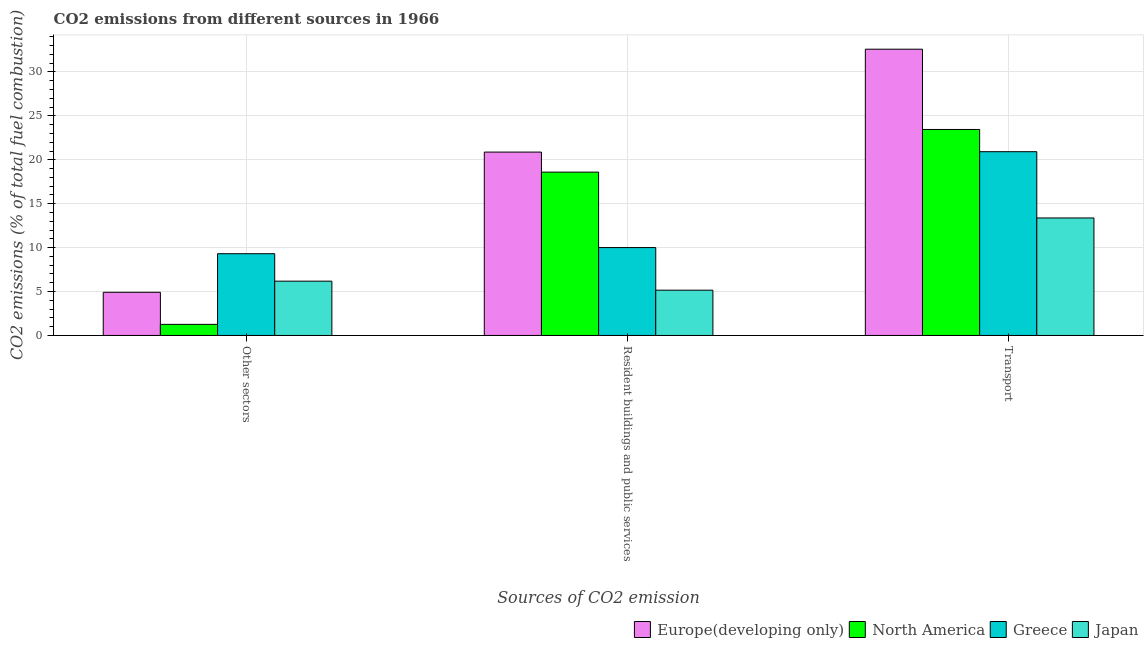How many groups of bars are there?
Provide a succinct answer. 3. Are the number of bars per tick equal to the number of legend labels?
Your response must be concise. Yes. How many bars are there on the 1st tick from the right?
Give a very brief answer. 4. What is the label of the 3rd group of bars from the left?
Provide a succinct answer. Transport. What is the percentage of co2 emissions from other sectors in Japan?
Offer a terse response. 6.18. Across all countries, what is the maximum percentage of co2 emissions from other sectors?
Provide a succinct answer. 9.31. Across all countries, what is the minimum percentage of co2 emissions from transport?
Give a very brief answer. 13.38. In which country was the percentage of co2 emissions from resident buildings and public services maximum?
Keep it short and to the point. Europe(developing only). In which country was the percentage of co2 emissions from other sectors minimum?
Make the answer very short. North America. What is the total percentage of co2 emissions from transport in the graph?
Keep it short and to the point. 90.35. What is the difference between the percentage of co2 emissions from transport in North America and that in Europe(developing only)?
Offer a very short reply. -9.14. What is the difference between the percentage of co2 emissions from other sectors in Europe(developing only) and the percentage of co2 emissions from resident buildings and public services in North America?
Ensure brevity in your answer.  -13.68. What is the average percentage of co2 emissions from resident buildings and public services per country?
Provide a succinct answer. 13.66. What is the difference between the percentage of co2 emissions from other sectors and percentage of co2 emissions from transport in North America?
Ensure brevity in your answer.  -22.19. What is the ratio of the percentage of co2 emissions from other sectors in Greece to that in North America?
Provide a short and direct response. 7.37. Is the percentage of co2 emissions from other sectors in Greece less than that in Europe(developing only)?
Offer a very short reply. No. What is the difference between the highest and the second highest percentage of co2 emissions from resident buildings and public services?
Provide a short and direct response. 2.28. What is the difference between the highest and the lowest percentage of co2 emissions from other sectors?
Offer a terse response. 8.04. In how many countries, is the percentage of co2 emissions from other sectors greater than the average percentage of co2 emissions from other sectors taken over all countries?
Your response must be concise. 2. What does the 2nd bar from the left in Other sectors represents?
Ensure brevity in your answer.  North America. What does the 2nd bar from the right in Other sectors represents?
Provide a short and direct response. Greece. Where does the legend appear in the graph?
Your response must be concise. Bottom right. How are the legend labels stacked?
Give a very brief answer. Horizontal. What is the title of the graph?
Your answer should be compact. CO2 emissions from different sources in 1966. What is the label or title of the X-axis?
Offer a terse response. Sources of CO2 emission. What is the label or title of the Y-axis?
Offer a very short reply. CO2 emissions (% of total fuel combustion). What is the CO2 emissions (% of total fuel combustion) in Europe(developing only) in Other sectors?
Your response must be concise. 4.92. What is the CO2 emissions (% of total fuel combustion) of North America in Other sectors?
Offer a terse response. 1.26. What is the CO2 emissions (% of total fuel combustion) of Greece in Other sectors?
Your answer should be compact. 9.31. What is the CO2 emissions (% of total fuel combustion) of Japan in Other sectors?
Ensure brevity in your answer.  6.18. What is the CO2 emissions (% of total fuel combustion) in Europe(developing only) in Resident buildings and public services?
Your answer should be compact. 20.88. What is the CO2 emissions (% of total fuel combustion) of North America in Resident buildings and public services?
Provide a succinct answer. 18.6. What is the CO2 emissions (% of total fuel combustion) of Greece in Resident buildings and public services?
Provide a succinct answer. 10.01. What is the CO2 emissions (% of total fuel combustion) of Japan in Resident buildings and public services?
Make the answer very short. 5.16. What is the CO2 emissions (% of total fuel combustion) in Europe(developing only) in Transport?
Your answer should be very brief. 32.59. What is the CO2 emissions (% of total fuel combustion) of North America in Transport?
Your response must be concise. 23.45. What is the CO2 emissions (% of total fuel combustion) of Greece in Transport?
Your answer should be compact. 20.92. What is the CO2 emissions (% of total fuel combustion) of Japan in Transport?
Keep it short and to the point. 13.38. Across all Sources of CO2 emission, what is the maximum CO2 emissions (% of total fuel combustion) in Europe(developing only)?
Provide a succinct answer. 32.59. Across all Sources of CO2 emission, what is the maximum CO2 emissions (% of total fuel combustion) of North America?
Give a very brief answer. 23.45. Across all Sources of CO2 emission, what is the maximum CO2 emissions (% of total fuel combustion) in Greece?
Offer a terse response. 20.92. Across all Sources of CO2 emission, what is the maximum CO2 emissions (% of total fuel combustion) in Japan?
Keep it short and to the point. 13.38. Across all Sources of CO2 emission, what is the minimum CO2 emissions (% of total fuel combustion) in Europe(developing only)?
Your answer should be very brief. 4.92. Across all Sources of CO2 emission, what is the minimum CO2 emissions (% of total fuel combustion) of North America?
Your answer should be very brief. 1.26. Across all Sources of CO2 emission, what is the minimum CO2 emissions (% of total fuel combustion) in Greece?
Offer a terse response. 9.31. Across all Sources of CO2 emission, what is the minimum CO2 emissions (% of total fuel combustion) of Japan?
Give a very brief answer. 5.16. What is the total CO2 emissions (% of total fuel combustion) of Europe(developing only) in the graph?
Give a very brief answer. 58.39. What is the total CO2 emissions (% of total fuel combustion) in North America in the graph?
Provide a short and direct response. 43.31. What is the total CO2 emissions (% of total fuel combustion) in Greece in the graph?
Keep it short and to the point. 40.24. What is the total CO2 emissions (% of total fuel combustion) of Japan in the graph?
Your answer should be compact. 24.72. What is the difference between the CO2 emissions (% of total fuel combustion) of Europe(developing only) in Other sectors and that in Resident buildings and public services?
Give a very brief answer. -15.96. What is the difference between the CO2 emissions (% of total fuel combustion) of North America in Other sectors and that in Resident buildings and public services?
Your answer should be compact. -17.33. What is the difference between the CO2 emissions (% of total fuel combustion) in Greece in Other sectors and that in Resident buildings and public services?
Your response must be concise. -0.7. What is the difference between the CO2 emissions (% of total fuel combustion) of Japan in Other sectors and that in Resident buildings and public services?
Offer a very short reply. 1.03. What is the difference between the CO2 emissions (% of total fuel combustion) of Europe(developing only) in Other sectors and that in Transport?
Keep it short and to the point. -27.68. What is the difference between the CO2 emissions (% of total fuel combustion) in North America in Other sectors and that in Transport?
Make the answer very short. -22.19. What is the difference between the CO2 emissions (% of total fuel combustion) in Greece in Other sectors and that in Transport?
Your answer should be very brief. -11.62. What is the difference between the CO2 emissions (% of total fuel combustion) of Japan in Other sectors and that in Transport?
Your answer should be compact. -7.2. What is the difference between the CO2 emissions (% of total fuel combustion) of Europe(developing only) in Resident buildings and public services and that in Transport?
Ensure brevity in your answer.  -11.71. What is the difference between the CO2 emissions (% of total fuel combustion) of North America in Resident buildings and public services and that in Transport?
Offer a terse response. -4.86. What is the difference between the CO2 emissions (% of total fuel combustion) of Greece in Resident buildings and public services and that in Transport?
Make the answer very short. -10.92. What is the difference between the CO2 emissions (% of total fuel combustion) in Japan in Resident buildings and public services and that in Transport?
Provide a short and direct response. -8.22. What is the difference between the CO2 emissions (% of total fuel combustion) in Europe(developing only) in Other sectors and the CO2 emissions (% of total fuel combustion) in North America in Resident buildings and public services?
Your answer should be compact. -13.68. What is the difference between the CO2 emissions (% of total fuel combustion) of Europe(developing only) in Other sectors and the CO2 emissions (% of total fuel combustion) of Greece in Resident buildings and public services?
Provide a short and direct response. -5.09. What is the difference between the CO2 emissions (% of total fuel combustion) in Europe(developing only) in Other sectors and the CO2 emissions (% of total fuel combustion) in Japan in Resident buildings and public services?
Make the answer very short. -0.24. What is the difference between the CO2 emissions (% of total fuel combustion) in North America in Other sectors and the CO2 emissions (% of total fuel combustion) in Greece in Resident buildings and public services?
Provide a succinct answer. -8.74. What is the difference between the CO2 emissions (% of total fuel combustion) in North America in Other sectors and the CO2 emissions (% of total fuel combustion) in Japan in Resident buildings and public services?
Keep it short and to the point. -3.89. What is the difference between the CO2 emissions (% of total fuel combustion) of Greece in Other sectors and the CO2 emissions (% of total fuel combustion) of Japan in Resident buildings and public services?
Keep it short and to the point. 4.15. What is the difference between the CO2 emissions (% of total fuel combustion) in Europe(developing only) in Other sectors and the CO2 emissions (% of total fuel combustion) in North America in Transport?
Make the answer very short. -18.54. What is the difference between the CO2 emissions (% of total fuel combustion) in Europe(developing only) in Other sectors and the CO2 emissions (% of total fuel combustion) in Greece in Transport?
Provide a short and direct response. -16.01. What is the difference between the CO2 emissions (% of total fuel combustion) in Europe(developing only) in Other sectors and the CO2 emissions (% of total fuel combustion) in Japan in Transport?
Offer a terse response. -8.46. What is the difference between the CO2 emissions (% of total fuel combustion) of North America in Other sectors and the CO2 emissions (% of total fuel combustion) of Greece in Transport?
Your answer should be compact. -19.66. What is the difference between the CO2 emissions (% of total fuel combustion) of North America in Other sectors and the CO2 emissions (% of total fuel combustion) of Japan in Transport?
Ensure brevity in your answer.  -12.12. What is the difference between the CO2 emissions (% of total fuel combustion) in Greece in Other sectors and the CO2 emissions (% of total fuel combustion) in Japan in Transport?
Offer a terse response. -4.07. What is the difference between the CO2 emissions (% of total fuel combustion) of Europe(developing only) in Resident buildings and public services and the CO2 emissions (% of total fuel combustion) of North America in Transport?
Provide a short and direct response. -2.57. What is the difference between the CO2 emissions (% of total fuel combustion) of Europe(developing only) in Resident buildings and public services and the CO2 emissions (% of total fuel combustion) of Greece in Transport?
Keep it short and to the point. -0.04. What is the difference between the CO2 emissions (% of total fuel combustion) of Europe(developing only) in Resident buildings and public services and the CO2 emissions (% of total fuel combustion) of Japan in Transport?
Give a very brief answer. 7.5. What is the difference between the CO2 emissions (% of total fuel combustion) of North America in Resident buildings and public services and the CO2 emissions (% of total fuel combustion) of Greece in Transport?
Your response must be concise. -2.33. What is the difference between the CO2 emissions (% of total fuel combustion) in North America in Resident buildings and public services and the CO2 emissions (% of total fuel combustion) in Japan in Transport?
Provide a short and direct response. 5.22. What is the difference between the CO2 emissions (% of total fuel combustion) in Greece in Resident buildings and public services and the CO2 emissions (% of total fuel combustion) in Japan in Transport?
Offer a terse response. -3.37. What is the average CO2 emissions (% of total fuel combustion) in Europe(developing only) per Sources of CO2 emission?
Make the answer very short. 19.46. What is the average CO2 emissions (% of total fuel combustion) in North America per Sources of CO2 emission?
Your response must be concise. 14.44. What is the average CO2 emissions (% of total fuel combustion) of Greece per Sources of CO2 emission?
Give a very brief answer. 13.41. What is the average CO2 emissions (% of total fuel combustion) in Japan per Sources of CO2 emission?
Ensure brevity in your answer.  8.24. What is the difference between the CO2 emissions (% of total fuel combustion) of Europe(developing only) and CO2 emissions (% of total fuel combustion) of North America in Other sectors?
Keep it short and to the point. 3.65. What is the difference between the CO2 emissions (% of total fuel combustion) in Europe(developing only) and CO2 emissions (% of total fuel combustion) in Greece in Other sectors?
Your response must be concise. -4.39. What is the difference between the CO2 emissions (% of total fuel combustion) in Europe(developing only) and CO2 emissions (% of total fuel combustion) in Japan in Other sectors?
Ensure brevity in your answer.  -1.27. What is the difference between the CO2 emissions (% of total fuel combustion) in North America and CO2 emissions (% of total fuel combustion) in Greece in Other sectors?
Offer a terse response. -8.04. What is the difference between the CO2 emissions (% of total fuel combustion) of North America and CO2 emissions (% of total fuel combustion) of Japan in Other sectors?
Your response must be concise. -4.92. What is the difference between the CO2 emissions (% of total fuel combustion) of Greece and CO2 emissions (% of total fuel combustion) of Japan in Other sectors?
Make the answer very short. 3.12. What is the difference between the CO2 emissions (% of total fuel combustion) in Europe(developing only) and CO2 emissions (% of total fuel combustion) in North America in Resident buildings and public services?
Provide a short and direct response. 2.28. What is the difference between the CO2 emissions (% of total fuel combustion) in Europe(developing only) and CO2 emissions (% of total fuel combustion) in Greece in Resident buildings and public services?
Your response must be concise. 10.87. What is the difference between the CO2 emissions (% of total fuel combustion) of Europe(developing only) and CO2 emissions (% of total fuel combustion) of Japan in Resident buildings and public services?
Your answer should be very brief. 15.72. What is the difference between the CO2 emissions (% of total fuel combustion) of North America and CO2 emissions (% of total fuel combustion) of Greece in Resident buildings and public services?
Make the answer very short. 8.59. What is the difference between the CO2 emissions (% of total fuel combustion) of North America and CO2 emissions (% of total fuel combustion) of Japan in Resident buildings and public services?
Provide a short and direct response. 13.44. What is the difference between the CO2 emissions (% of total fuel combustion) of Greece and CO2 emissions (% of total fuel combustion) of Japan in Resident buildings and public services?
Offer a terse response. 4.85. What is the difference between the CO2 emissions (% of total fuel combustion) in Europe(developing only) and CO2 emissions (% of total fuel combustion) in North America in Transport?
Give a very brief answer. 9.14. What is the difference between the CO2 emissions (% of total fuel combustion) of Europe(developing only) and CO2 emissions (% of total fuel combustion) of Greece in Transport?
Make the answer very short. 11.67. What is the difference between the CO2 emissions (% of total fuel combustion) in Europe(developing only) and CO2 emissions (% of total fuel combustion) in Japan in Transport?
Your response must be concise. 19.22. What is the difference between the CO2 emissions (% of total fuel combustion) in North America and CO2 emissions (% of total fuel combustion) in Greece in Transport?
Your response must be concise. 2.53. What is the difference between the CO2 emissions (% of total fuel combustion) of North America and CO2 emissions (% of total fuel combustion) of Japan in Transport?
Your answer should be compact. 10.07. What is the difference between the CO2 emissions (% of total fuel combustion) of Greece and CO2 emissions (% of total fuel combustion) of Japan in Transport?
Your answer should be very brief. 7.55. What is the ratio of the CO2 emissions (% of total fuel combustion) of Europe(developing only) in Other sectors to that in Resident buildings and public services?
Make the answer very short. 0.24. What is the ratio of the CO2 emissions (% of total fuel combustion) of North America in Other sectors to that in Resident buildings and public services?
Your answer should be compact. 0.07. What is the ratio of the CO2 emissions (% of total fuel combustion) of Greece in Other sectors to that in Resident buildings and public services?
Give a very brief answer. 0.93. What is the ratio of the CO2 emissions (% of total fuel combustion) in Japan in Other sectors to that in Resident buildings and public services?
Make the answer very short. 1.2. What is the ratio of the CO2 emissions (% of total fuel combustion) of Europe(developing only) in Other sectors to that in Transport?
Give a very brief answer. 0.15. What is the ratio of the CO2 emissions (% of total fuel combustion) of North America in Other sectors to that in Transport?
Your answer should be very brief. 0.05. What is the ratio of the CO2 emissions (% of total fuel combustion) of Greece in Other sectors to that in Transport?
Give a very brief answer. 0.44. What is the ratio of the CO2 emissions (% of total fuel combustion) of Japan in Other sectors to that in Transport?
Ensure brevity in your answer.  0.46. What is the ratio of the CO2 emissions (% of total fuel combustion) of Europe(developing only) in Resident buildings and public services to that in Transport?
Offer a very short reply. 0.64. What is the ratio of the CO2 emissions (% of total fuel combustion) of North America in Resident buildings and public services to that in Transport?
Make the answer very short. 0.79. What is the ratio of the CO2 emissions (% of total fuel combustion) of Greece in Resident buildings and public services to that in Transport?
Your answer should be very brief. 0.48. What is the ratio of the CO2 emissions (% of total fuel combustion) in Japan in Resident buildings and public services to that in Transport?
Give a very brief answer. 0.39. What is the difference between the highest and the second highest CO2 emissions (% of total fuel combustion) in Europe(developing only)?
Your response must be concise. 11.71. What is the difference between the highest and the second highest CO2 emissions (% of total fuel combustion) in North America?
Your answer should be compact. 4.86. What is the difference between the highest and the second highest CO2 emissions (% of total fuel combustion) in Greece?
Provide a short and direct response. 10.92. What is the difference between the highest and the second highest CO2 emissions (% of total fuel combustion) of Japan?
Ensure brevity in your answer.  7.2. What is the difference between the highest and the lowest CO2 emissions (% of total fuel combustion) in Europe(developing only)?
Your answer should be very brief. 27.68. What is the difference between the highest and the lowest CO2 emissions (% of total fuel combustion) in North America?
Offer a terse response. 22.19. What is the difference between the highest and the lowest CO2 emissions (% of total fuel combustion) in Greece?
Give a very brief answer. 11.62. What is the difference between the highest and the lowest CO2 emissions (% of total fuel combustion) of Japan?
Your response must be concise. 8.22. 